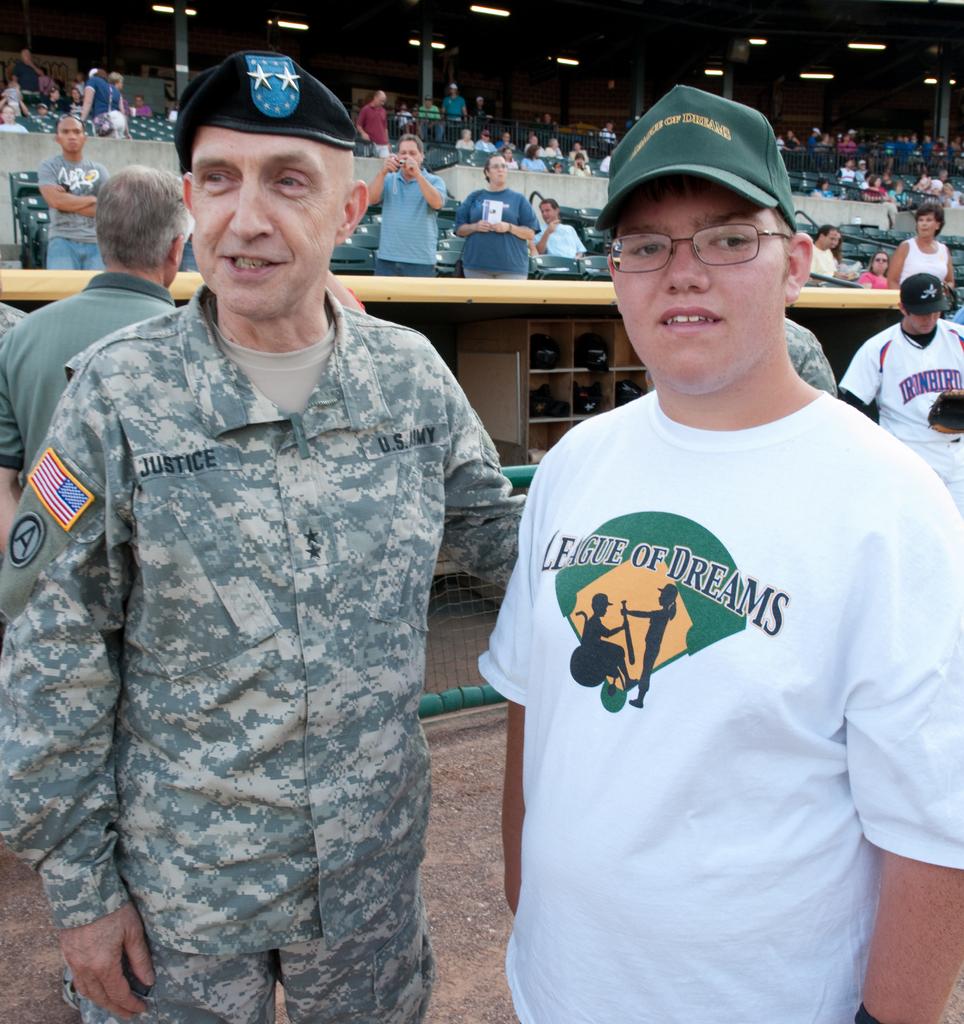What is on the right shirt?
Your answer should be compact. League of dreams. 